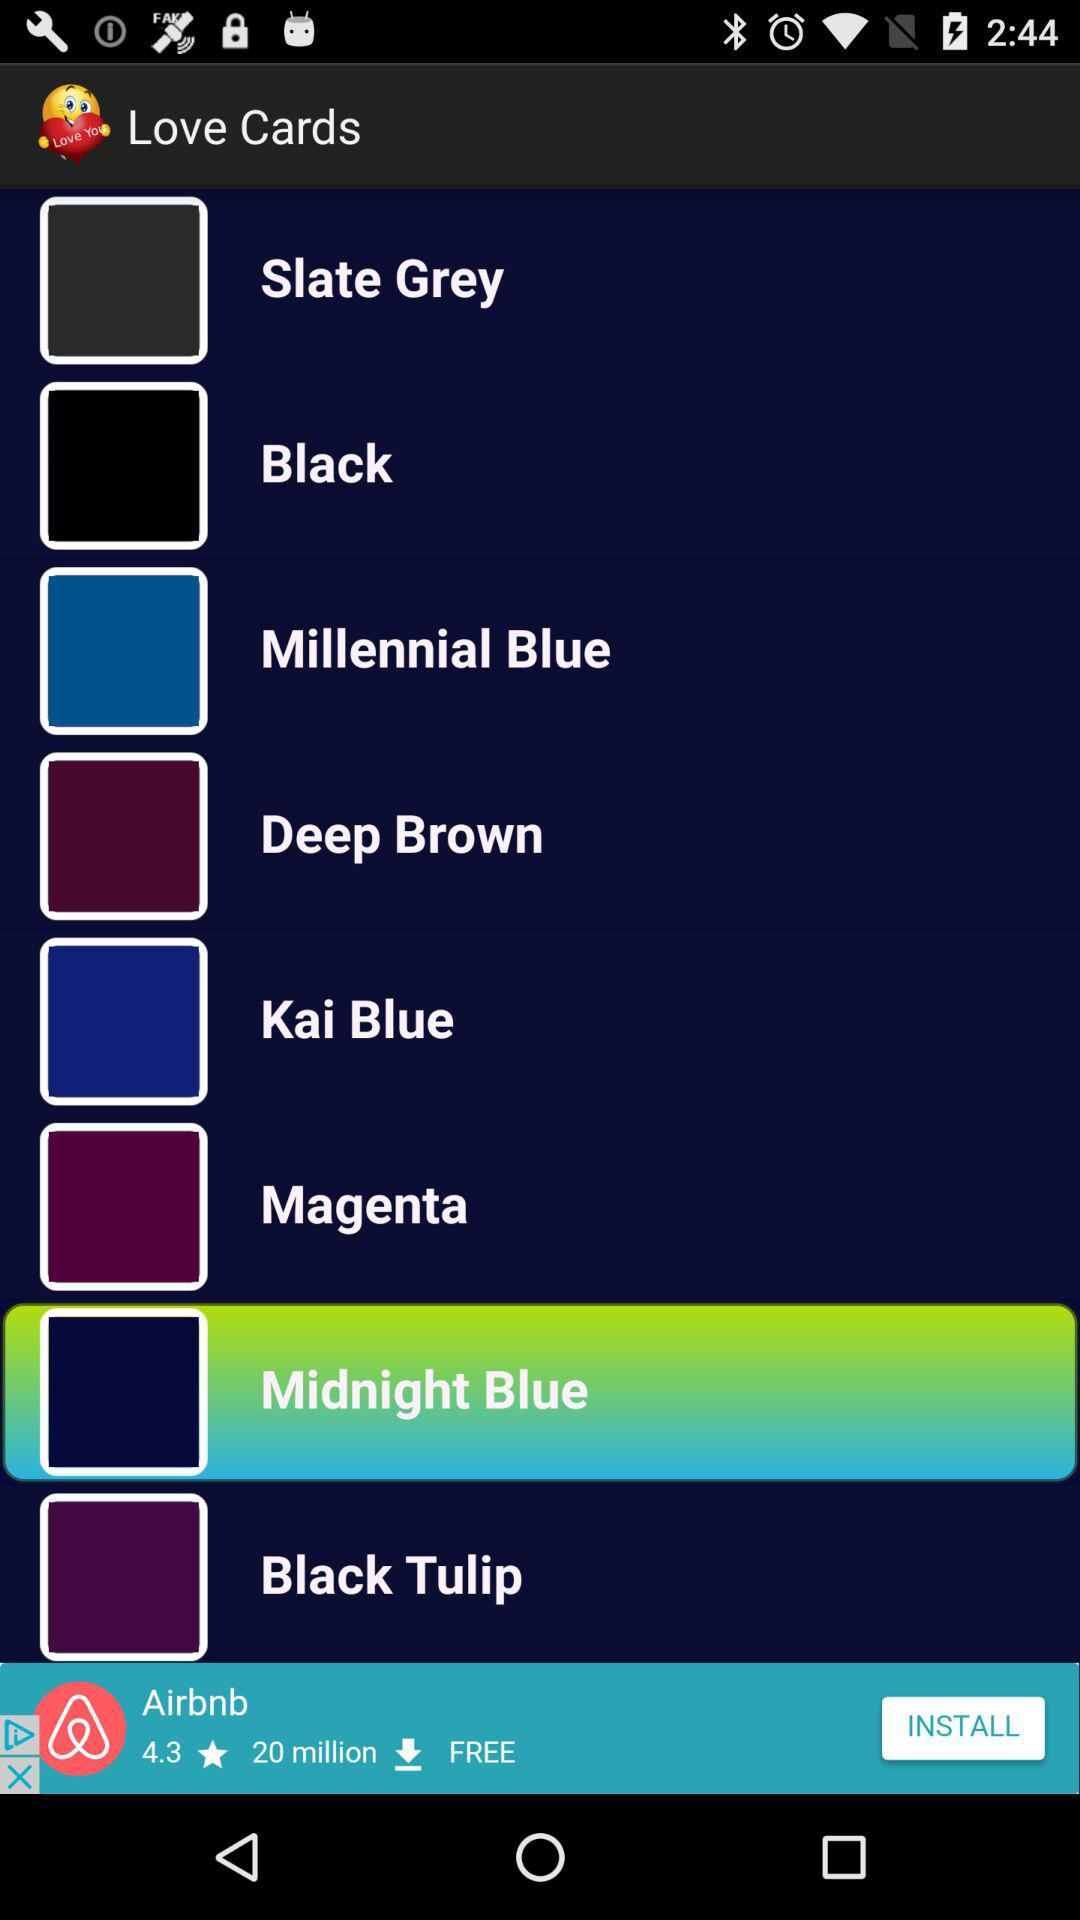Which color in "Love Cards" is selected? The selected color is midnight blue. 